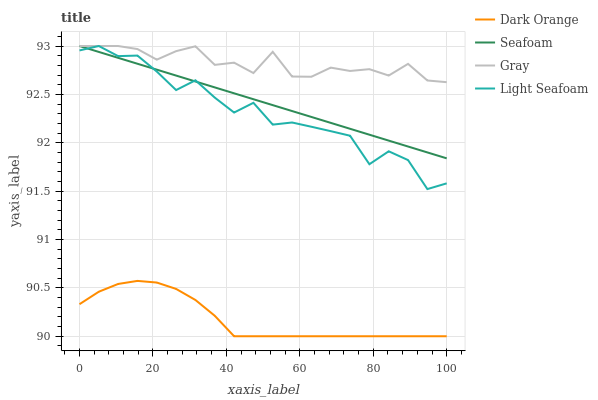Does Dark Orange have the minimum area under the curve?
Answer yes or no. Yes. Does Gray have the maximum area under the curve?
Answer yes or no. Yes. Does Light Seafoam have the minimum area under the curve?
Answer yes or no. No. Does Light Seafoam have the maximum area under the curve?
Answer yes or no. No. Is Seafoam the smoothest?
Answer yes or no. Yes. Is Light Seafoam the roughest?
Answer yes or no. Yes. Is Light Seafoam the smoothest?
Answer yes or no. No. Is Seafoam the roughest?
Answer yes or no. No. Does Dark Orange have the lowest value?
Answer yes or no. Yes. Does Light Seafoam have the lowest value?
Answer yes or no. No. Does Gray have the highest value?
Answer yes or no. Yes. Is Dark Orange less than Seafoam?
Answer yes or no. Yes. Is Gray greater than Dark Orange?
Answer yes or no. Yes. Does Light Seafoam intersect Gray?
Answer yes or no. Yes. Is Light Seafoam less than Gray?
Answer yes or no. No. Is Light Seafoam greater than Gray?
Answer yes or no. No. Does Dark Orange intersect Seafoam?
Answer yes or no. No. 